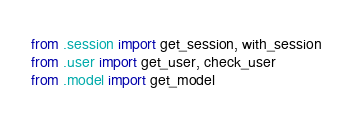Convert code to text. <code><loc_0><loc_0><loc_500><loc_500><_Python_>from .session import get_session, with_session
from .user import get_user, check_user
from .model import get_model
</code> 